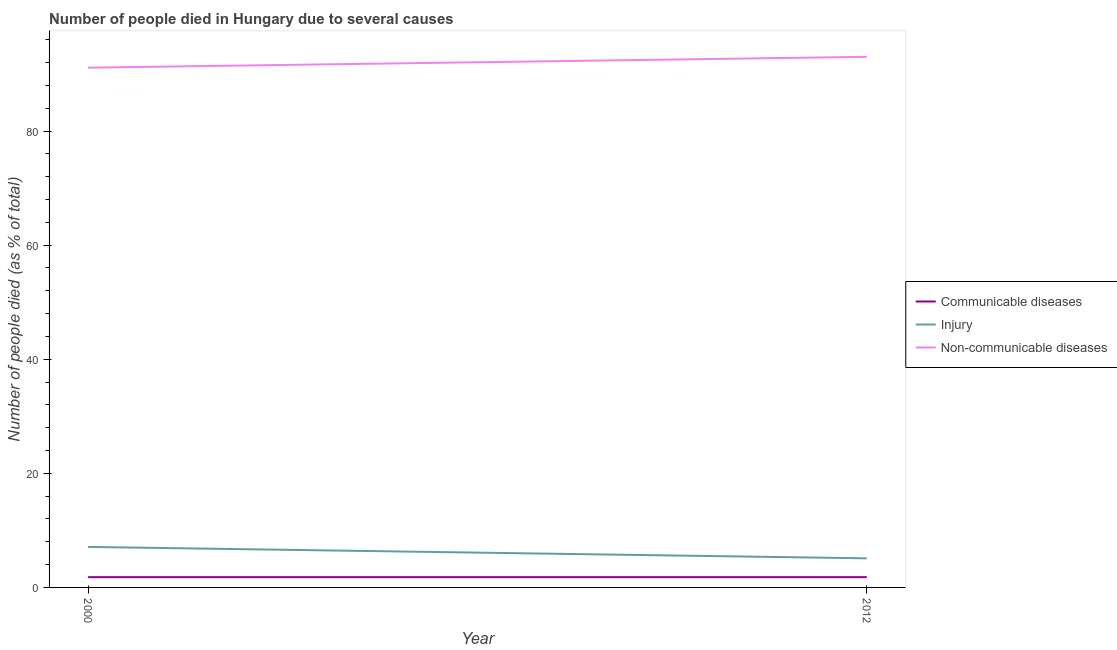How many different coloured lines are there?
Your answer should be compact. 3. What is the number of people who dies of non-communicable diseases in 2000?
Your response must be concise. 91.1. Across all years, what is the maximum number of people who dies of non-communicable diseases?
Provide a succinct answer. 93. Across all years, what is the minimum number of people who died of communicable diseases?
Your answer should be compact. 1.8. In which year was the number of people who dies of non-communicable diseases maximum?
Your answer should be very brief. 2012. In which year was the number of people who dies of non-communicable diseases minimum?
Your response must be concise. 2000. What is the total number of people who died of communicable diseases in the graph?
Your answer should be compact. 3.6. What is the difference between the number of people who died of communicable diseases in 2012 and the number of people who dies of non-communicable diseases in 2000?
Offer a very short reply. -89.3. What is the average number of people who dies of non-communicable diseases per year?
Your answer should be compact. 92.05. In the year 2000, what is the difference between the number of people who died of communicable diseases and number of people who died of injury?
Your answer should be very brief. -5.3. In how many years, is the number of people who died of communicable diseases greater than 88 %?
Make the answer very short. 0. What is the ratio of the number of people who dies of non-communicable diseases in 2000 to that in 2012?
Keep it short and to the point. 0.98. Is the number of people who died of communicable diseases in 2000 less than that in 2012?
Provide a short and direct response. No. In how many years, is the number of people who died of injury greater than the average number of people who died of injury taken over all years?
Give a very brief answer. 1. Is the number of people who dies of non-communicable diseases strictly less than the number of people who died of injury over the years?
Give a very brief answer. No. How many years are there in the graph?
Provide a short and direct response. 2. Where does the legend appear in the graph?
Ensure brevity in your answer.  Center right. What is the title of the graph?
Provide a succinct answer. Number of people died in Hungary due to several causes. What is the label or title of the Y-axis?
Make the answer very short. Number of people died (as % of total). What is the Number of people died (as % of total) in Communicable diseases in 2000?
Your answer should be compact. 1.8. What is the Number of people died (as % of total) in Injury in 2000?
Your answer should be compact. 7.1. What is the Number of people died (as % of total) in Non-communicable diseases in 2000?
Provide a succinct answer. 91.1. What is the Number of people died (as % of total) in Communicable diseases in 2012?
Provide a succinct answer. 1.8. What is the Number of people died (as % of total) of Non-communicable diseases in 2012?
Give a very brief answer. 93. Across all years, what is the maximum Number of people died (as % of total) of Injury?
Offer a very short reply. 7.1. Across all years, what is the maximum Number of people died (as % of total) of Non-communicable diseases?
Make the answer very short. 93. Across all years, what is the minimum Number of people died (as % of total) of Communicable diseases?
Offer a terse response. 1.8. Across all years, what is the minimum Number of people died (as % of total) of Injury?
Make the answer very short. 5.1. Across all years, what is the minimum Number of people died (as % of total) in Non-communicable diseases?
Your answer should be compact. 91.1. What is the total Number of people died (as % of total) in Communicable diseases in the graph?
Provide a succinct answer. 3.6. What is the total Number of people died (as % of total) in Non-communicable diseases in the graph?
Your answer should be compact. 184.1. What is the difference between the Number of people died (as % of total) in Injury in 2000 and that in 2012?
Give a very brief answer. 2. What is the difference between the Number of people died (as % of total) in Communicable diseases in 2000 and the Number of people died (as % of total) in Injury in 2012?
Provide a succinct answer. -3.3. What is the difference between the Number of people died (as % of total) in Communicable diseases in 2000 and the Number of people died (as % of total) in Non-communicable diseases in 2012?
Your answer should be compact. -91.2. What is the difference between the Number of people died (as % of total) of Injury in 2000 and the Number of people died (as % of total) of Non-communicable diseases in 2012?
Your answer should be very brief. -85.9. What is the average Number of people died (as % of total) in Injury per year?
Give a very brief answer. 6.1. What is the average Number of people died (as % of total) in Non-communicable diseases per year?
Give a very brief answer. 92.05. In the year 2000, what is the difference between the Number of people died (as % of total) in Communicable diseases and Number of people died (as % of total) in Non-communicable diseases?
Your answer should be very brief. -89.3. In the year 2000, what is the difference between the Number of people died (as % of total) of Injury and Number of people died (as % of total) of Non-communicable diseases?
Ensure brevity in your answer.  -84. In the year 2012, what is the difference between the Number of people died (as % of total) of Communicable diseases and Number of people died (as % of total) of Non-communicable diseases?
Keep it short and to the point. -91.2. In the year 2012, what is the difference between the Number of people died (as % of total) of Injury and Number of people died (as % of total) of Non-communicable diseases?
Give a very brief answer. -87.9. What is the ratio of the Number of people died (as % of total) in Communicable diseases in 2000 to that in 2012?
Offer a terse response. 1. What is the ratio of the Number of people died (as % of total) in Injury in 2000 to that in 2012?
Make the answer very short. 1.39. What is the ratio of the Number of people died (as % of total) in Non-communicable diseases in 2000 to that in 2012?
Your response must be concise. 0.98. What is the difference between the highest and the second highest Number of people died (as % of total) in Communicable diseases?
Provide a short and direct response. 0. What is the difference between the highest and the second highest Number of people died (as % of total) of Non-communicable diseases?
Offer a terse response. 1.9. What is the difference between the highest and the lowest Number of people died (as % of total) in Communicable diseases?
Offer a very short reply. 0. What is the difference between the highest and the lowest Number of people died (as % of total) in Injury?
Keep it short and to the point. 2. 